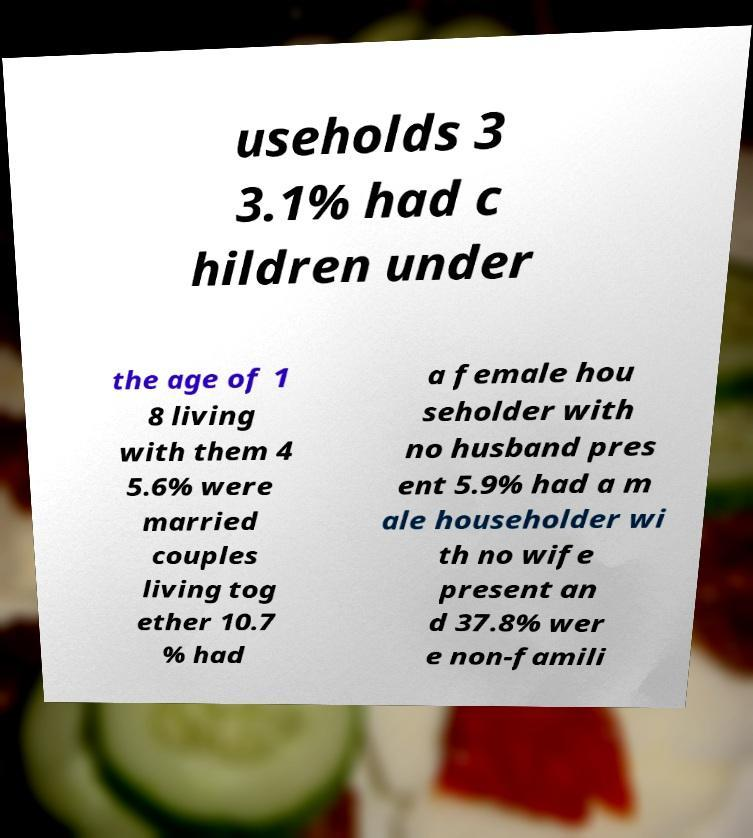Can you accurately transcribe the text from the provided image for me? useholds 3 3.1% had c hildren under the age of 1 8 living with them 4 5.6% were married couples living tog ether 10.7 % had a female hou seholder with no husband pres ent 5.9% had a m ale householder wi th no wife present an d 37.8% wer e non-famili 